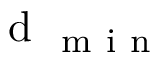Convert formula to latex. <formula><loc_0><loc_0><loc_500><loc_500>d _ { m i n }</formula> 